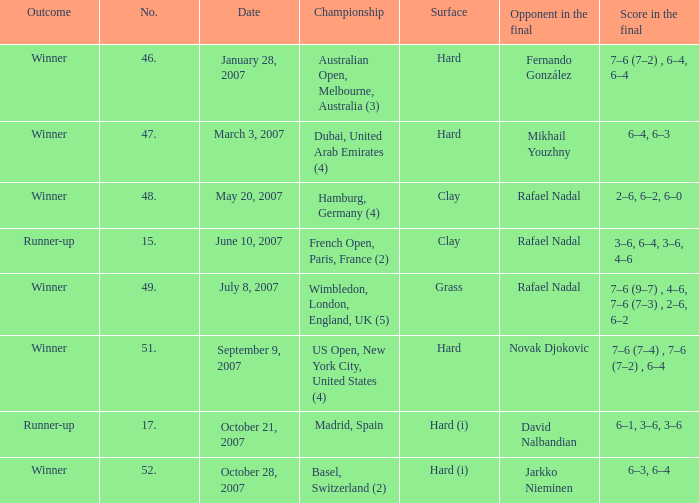Where the success is winner and surface is hard (i), what is the no.? 52.0. 